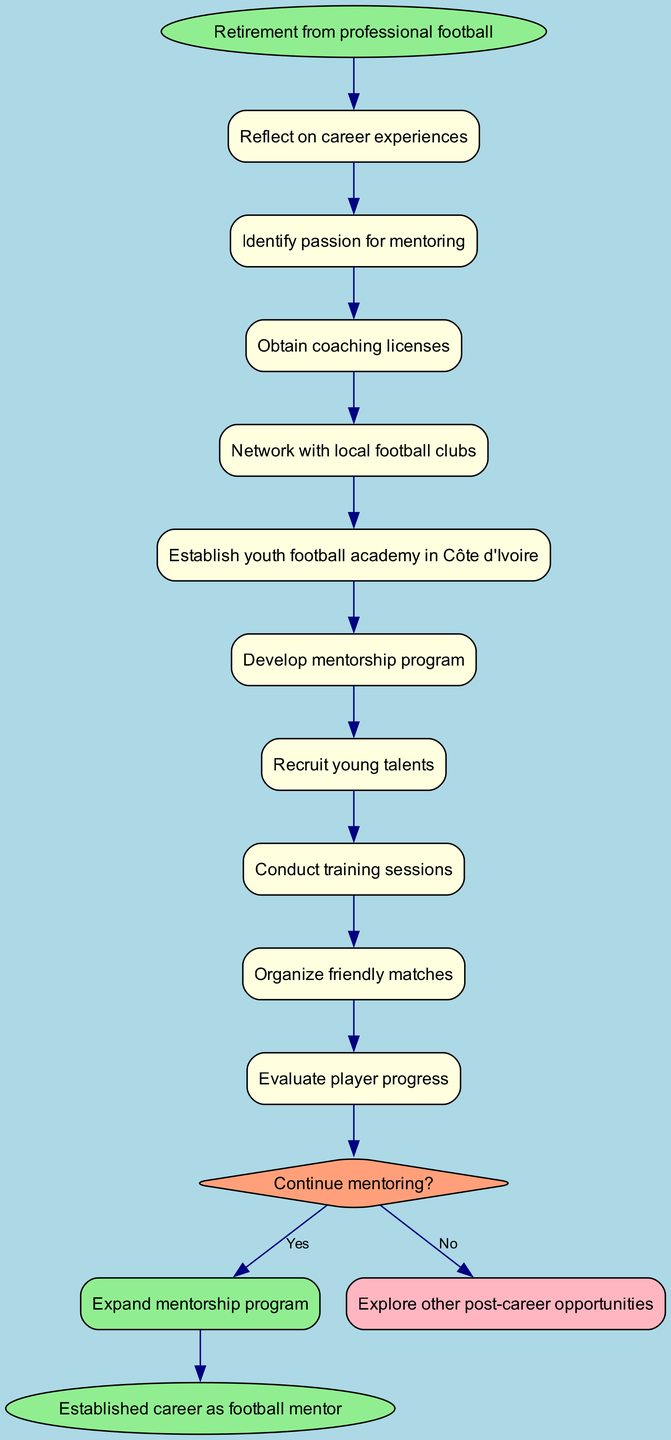What is the starting point of the activity diagram? The starting point of the activity diagram is explicitly shown as "Retirement from professional football". This is where the entire journey begins.
Answer: Retirement from professional football How many activities are listed in the diagram? By counting the items in the "activities" section of the diagram, there are a total of 9 distinct activities that define the journey.
Answer: 9 What is the first activity after retirement? The first activity listed in the sequence of the diagram is "Reflect on career experiences", which follows directly after the starting point.
Answer: Reflect on career experiences What is the decision point in the diagram? The diagram contains a specific decision point that asks the question "Continue mentoring?". It is shown in a diamond shape, indicating a choice that must be made.
Answer: Continue mentoring? What happens if the decision is "No"? If the decision made at the diamond ("Continue mentoring?") is "No", the flow directs to "Explore other post-career opportunities", indicating the alternative path available.
Answer: Explore other post-career opportunities What is the last activity before the decision point? The last activity before reaching the decision point is "Evaluate player progress", which indicates an evaluation step in the mentoring process prior to making the decision.
Answer: Evaluate player progress In what shape is the decision point represented? The decision point is represented in a diamond shape, commonly used in activity diagrams to signify a branching point based on a yes/no question.
Answer: Diamond What outcome leads to the end node? After the decision is made with a "Yes", the flow moves directly to the end node, resulting in "Established career as football mentor", indicating successful completion of the mentoring journey.
Answer: Established career as football mentor What is the activity that follows "Network with local football clubs"? The activity that immediately follows "Network with local football clubs" is "Establish youth football academy in Côte d'Ivoire", indicating the next step in the transition.
Answer: Establish youth football academy in Côte d'Ivoire 